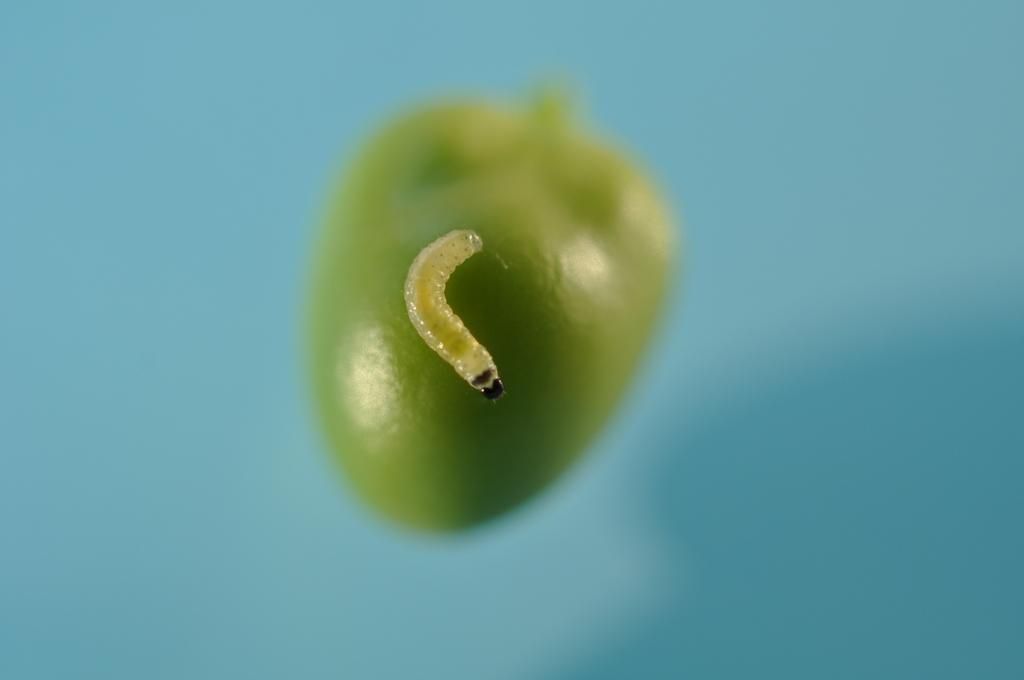What is the main subject in the foreground of the image? There is a worm in the foreground of the image. What is the worm resting on? The worm is on a green object. Can you describe the background of the image? The background of the image is blurred. What type of vein can be seen in the image? There is no vein present in the image; it features a worm on a green object with a blurred background. 